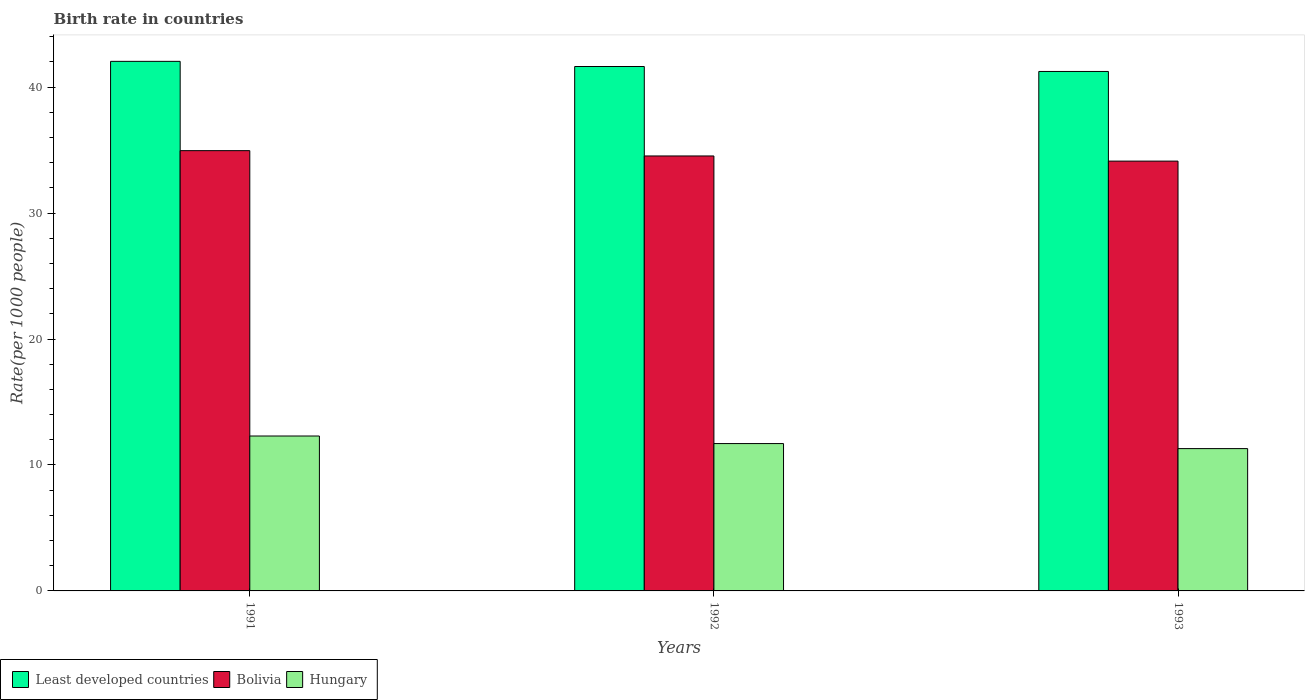How many different coloured bars are there?
Ensure brevity in your answer.  3. How many groups of bars are there?
Provide a short and direct response. 3. Are the number of bars per tick equal to the number of legend labels?
Offer a terse response. Yes. How many bars are there on the 2nd tick from the left?
Keep it short and to the point. 3. In how many cases, is the number of bars for a given year not equal to the number of legend labels?
Offer a terse response. 0. What is the birth rate in Least developed countries in 1992?
Provide a succinct answer. 41.64. Across all years, what is the maximum birth rate in Least developed countries?
Give a very brief answer. 42.05. Across all years, what is the minimum birth rate in Least developed countries?
Your response must be concise. 41.25. In which year was the birth rate in Bolivia minimum?
Your answer should be compact. 1993. What is the total birth rate in Least developed countries in the graph?
Your response must be concise. 124.93. What is the difference between the birth rate in Least developed countries in 1991 and that in 1992?
Make the answer very short. 0.41. What is the difference between the birth rate in Hungary in 1993 and the birth rate in Bolivia in 1991?
Give a very brief answer. -23.66. What is the average birth rate in Hungary per year?
Offer a very short reply. 11.77. In the year 1992, what is the difference between the birth rate in Hungary and birth rate in Bolivia?
Your response must be concise. -22.84. What is the ratio of the birth rate in Hungary in 1992 to that in 1993?
Your response must be concise. 1.04. Is the birth rate in Hungary in 1991 less than that in 1992?
Keep it short and to the point. No. Is the difference between the birth rate in Hungary in 1991 and 1993 greater than the difference between the birth rate in Bolivia in 1991 and 1993?
Offer a terse response. Yes. What is the difference between the highest and the second highest birth rate in Least developed countries?
Your answer should be very brief. 0.41. What is the difference between the highest and the lowest birth rate in Least developed countries?
Keep it short and to the point. 0.8. Is the sum of the birth rate in Hungary in 1991 and 1992 greater than the maximum birth rate in Bolivia across all years?
Give a very brief answer. No. What does the 1st bar from the left in 1991 represents?
Your answer should be compact. Least developed countries. What does the 1st bar from the right in 1991 represents?
Make the answer very short. Hungary. Are all the bars in the graph horizontal?
Your answer should be very brief. No. What is the difference between two consecutive major ticks on the Y-axis?
Your answer should be very brief. 10. Does the graph contain any zero values?
Your answer should be very brief. No. Does the graph contain grids?
Your response must be concise. No. Where does the legend appear in the graph?
Your response must be concise. Bottom left. What is the title of the graph?
Your response must be concise. Birth rate in countries. Does "Czech Republic" appear as one of the legend labels in the graph?
Give a very brief answer. No. What is the label or title of the X-axis?
Offer a very short reply. Years. What is the label or title of the Y-axis?
Your response must be concise. Rate(per 1000 people). What is the Rate(per 1000 people) of Least developed countries in 1991?
Provide a succinct answer. 42.05. What is the Rate(per 1000 people) of Bolivia in 1991?
Your answer should be compact. 34.96. What is the Rate(per 1000 people) in Hungary in 1991?
Your answer should be very brief. 12.3. What is the Rate(per 1000 people) of Least developed countries in 1992?
Your answer should be very brief. 41.64. What is the Rate(per 1000 people) in Bolivia in 1992?
Provide a short and direct response. 34.54. What is the Rate(per 1000 people) of Least developed countries in 1993?
Provide a short and direct response. 41.25. What is the Rate(per 1000 people) of Bolivia in 1993?
Offer a very short reply. 34.13. What is the Rate(per 1000 people) in Hungary in 1993?
Your response must be concise. 11.3. Across all years, what is the maximum Rate(per 1000 people) of Least developed countries?
Provide a short and direct response. 42.05. Across all years, what is the maximum Rate(per 1000 people) of Bolivia?
Your answer should be compact. 34.96. Across all years, what is the maximum Rate(per 1000 people) of Hungary?
Offer a very short reply. 12.3. Across all years, what is the minimum Rate(per 1000 people) of Least developed countries?
Give a very brief answer. 41.25. Across all years, what is the minimum Rate(per 1000 people) in Bolivia?
Your answer should be compact. 34.13. What is the total Rate(per 1000 people) in Least developed countries in the graph?
Your response must be concise. 124.93. What is the total Rate(per 1000 people) of Bolivia in the graph?
Give a very brief answer. 103.62. What is the total Rate(per 1000 people) in Hungary in the graph?
Your answer should be compact. 35.3. What is the difference between the Rate(per 1000 people) of Least developed countries in 1991 and that in 1992?
Keep it short and to the point. 0.41. What is the difference between the Rate(per 1000 people) of Bolivia in 1991 and that in 1992?
Provide a succinct answer. 0.42. What is the difference between the Rate(per 1000 people) of Least developed countries in 1991 and that in 1993?
Make the answer very short. 0.8. What is the difference between the Rate(per 1000 people) of Bolivia in 1991 and that in 1993?
Provide a short and direct response. 0.83. What is the difference between the Rate(per 1000 people) in Hungary in 1991 and that in 1993?
Your answer should be compact. 1. What is the difference between the Rate(per 1000 people) in Least developed countries in 1992 and that in 1993?
Ensure brevity in your answer.  0.39. What is the difference between the Rate(per 1000 people) in Bolivia in 1992 and that in 1993?
Your answer should be very brief. 0.41. What is the difference between the Rate(per 1000 people) of Least developed countries in 1991 and the Rate(per 1000 people) of Bolivia in 1992?
Provide a short and direct response. 7.51. What is the difference between the Rate(per 1000 people) of Least developed countries in 1991 and the Rate(per 1000 people) of Hungary in 1992?
Provide a succinct answer. 30.35. What is the difference between the Rate(per 1000 people) in Bolivia in 1991 and the Rate(per 1000 people) in Hungary in 1992?
Provide a short and direct response. 23.26. What is the difference between the Rate(per 1000 people) in Least developed countries in 1991 and the Rate(per 1000 people) in Bolivia in 1993?
Make the answer very short. 7.92. What is the difference between the Rate(per 1000 people) in Least developed countries in 1991 and the Rate(per 1000 people) in Hungary in 1993?
Provide a short and direct response. 30.75. What is the difference between the Rate(per 1000 people) of Bolivia in 1991 and the Rate(per 1000 people) of Hungary in 1993?
Your answer should be very brief. 23.66. What is the difference between the Rate(per 1000 people) in Least developed countries in 1992 and the Rate(per 1000 people) in Bolivia in 1993?
Your answer should be very brief. 7.51. What is the difference between the Rate(per 1000 people) in Least developed countries in 1992 and the Rate(per 1000 people) in Hungary in 1993?
Your response must be concise. 30.34. What is the difference between the Rate(per 1000 people) of Bolivia in 1992 and the Rate(per 1000 people) of Hungary in 1993?
Provide a short and direct response. 23.24. What is the average Rate(per 1000 people) in Least developed countries per year?
Ensure brevity in your answer.  41.64. What is the average Rate(per 1000 people) of Bolivia per year?
Make the answer very short. 34.54. What is the average Rate(per 1000 people) of Hungary per year?
Your answer should be compact. 11.77. In the year 1991, what is the difference between the Rate(per 1000 people) of Least developed countries and Rate(per 1000 people) of Bolivia?
Provide a short and direct response. 7.09. In the year 1991, what is the difference between the Rate(per 1000 people) of Least developed countries and Rate(per 1000 people) of Hungary?
Give a very brief answer. 29.75. In the year 1991, what is the difference between the Rate(per 1000 people) of Bolivia and Rate(per 1000 people) of Hungary?
Your answer should be very brief. 22.66. In the year 1992, what is the difference between the Rate(per 1000 people) of Least developed countries and Rate(per 1000 people) of Bolivia?
Ensure brevity in your answer.  7.1. In the year 1992, what is the difference between the Rate(per 1000 people) in Least developed countries and Rate(per 1000 people) in Hungary?
Offer a very short reply. 29.94. In the year 1992, what is the difference between the Rate(per 1000 people) in Bolivia and Rate(per 1000 people) in Hungary?
Offer a terse response. 22.84. In the year 1993, what is the difference between the Rate(per 1000 people) in Least developed countries and Rate(per 1000 people) in Bolivia?
Your answer should be compact. 7.12. In the year 1993, what is the difference between the Rate(per 1000 people) of Least developed countries and Rate(per 1000 people) of Hungary?
Provide a succinct answer. 29.95. In the year 1993, what is the difference between the Rate(per 1000 people) of Bolivia and Rate(per 1000 people) of Hungary?
Provide a succinct answer. 22.83. What is the ratio of the Rate(per 1000 people) in Least developed countries in 1991 to that in 1992?
Provide a short and direct response. 1.01. What is the ratio of the Rate(per 1000 people) in Bolivia in 1991 to that in 1992?
Ensure brevity in your answer.  1.01. What is the ratio of the Rate(per 1000 people) of Hungary in 1991 to that in 1992?
Provide a short and direct response. 1.05. What is the ratio of the Rate(per 1000 people) in Least developed countries in 1991 to that in 1993?
Ensure brevity in your answer.  1.02. What is the ratio of the Rate(per 1000 people) of Bolivia in 1991 to that in 1993?
Your response must be concise. 1.02. What is the ratio of the Rate(per 1000 people) of Hungary in 1991 to that in 1993?
Make the answer very short. 1.09. What is the ratio of the Rate(per 1000 people) of Least developed countries in 1992 to that in 1993?
Your answer should be compact. 1.01. What is the ratio of the Rate(per 1000 people) in Hungary in 1992 to that in 1993?
Ensure brevity in your answer.  1.04. What is the difference between the highest and the second highest Rate(per 1000 people) of Least developed countries?
Your answer should be very brief. 0.41. What is the difference between the highest and the second highest Rate(per 1000 people) of Bolivia?
Your answer should be very brief. 0.42. What is the difference between the highest and the lowest Rate(per 1000 people) in Least developed countries?
Your answer should be compact. 0.8. What is the difference between the highest and the lowest Rate(per 1000 people) of Bolivia?
Offer a terse response. 0.83. What is the difference between the highest and the lowest Rate(per 1000 people) in Hungary?
Provide a succinct answer. 1. 